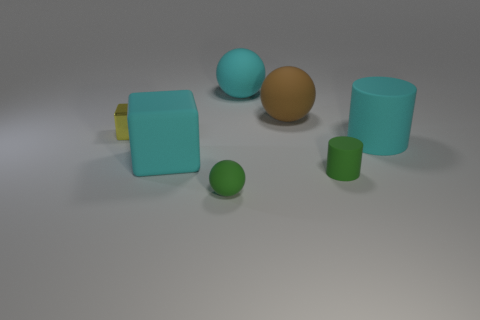Add 1 big cubes. How many objects exist? 8 Subtract all cubes. How many objects are left? 5 Subtract all small metal cubes. Subtract all big cyan rubber balls. How many objects are left? 5 Add 2 green matte spheres. How many green matte spheres are left? 3 Add 4 large purple matte balls. How many large purple matte balls exist? 4 Subtract 0 gray balls. How many objects are left? 7 